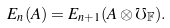<formula> <loc_0><loc_0><loc_500><loc_500>E _ { n } ( A ) = E _ { n + 1 } ( A \otimes \mho _ { \mathbb { F } } ) .</formula> 